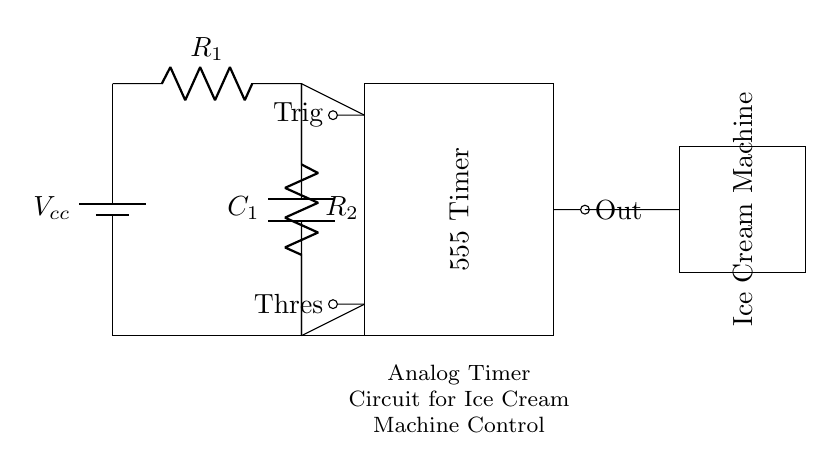What component is used for timing in this circuit? The timing function in this circuit is performed by the 555 Timer, which is configured to generate a periodic output based on the resistors and capacitor connected to it.
Answer: 555 Timer What are the two resistors labeled in the circuit? The resistors in the circuit are labeled as R1 and R2. Their values determine the timing interval when combined with the capacitor.
Answer: R1 and R2 What is the function of the capacitor in this circuit? The capacitor in the circuit, labeled C1, works in conjunction with the resistors to set the timing interval for the output pulse generated by the 555 Timer.
Answer: Timing interval How does the output from the 555 Timer affect the ice cream machine? The output from the 555 Timer directly controls the cycling of the ice cream machine by supplying it with power at defined intervals.
Answer: Activates machine What happens if R1 is increased in value? Increasing the value of R1 will increase the charging time of the capacitor, resulting in a longer delay for the output pulse from the 555 Timer and thus extending the cycling interval for the ice cream machine.
Answer: Longer delay How are the trigger and threshold pins configured in this 555 timer circuit? The trigger pin is connected to a voltage level that resets the timer when it falls below a certain threshold, while the threshold pin monitors the capacitor voltage to stop the timing cycle once the capacitor reaches the maximum charge.
Answer: Reset and monitor 